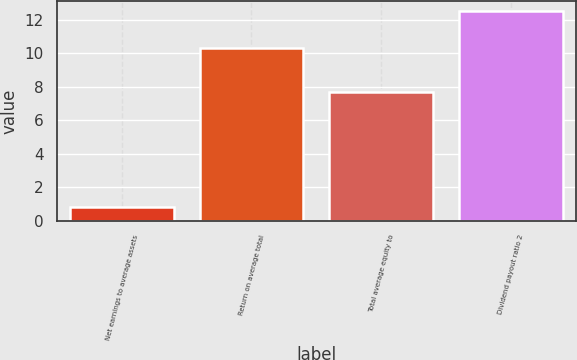Convert chart. <chart><loc_0><loc_0><loc_500><loc_500><bar_chart><fcel>Net earnings to average assets<fcel>Return on average total<fcel>Total average equity to<fcel>Dividend payout ratio 2<nl><fcel>0.8<fcel>10.3<fcel>7.7<fcel>12.5<nl></chart> 